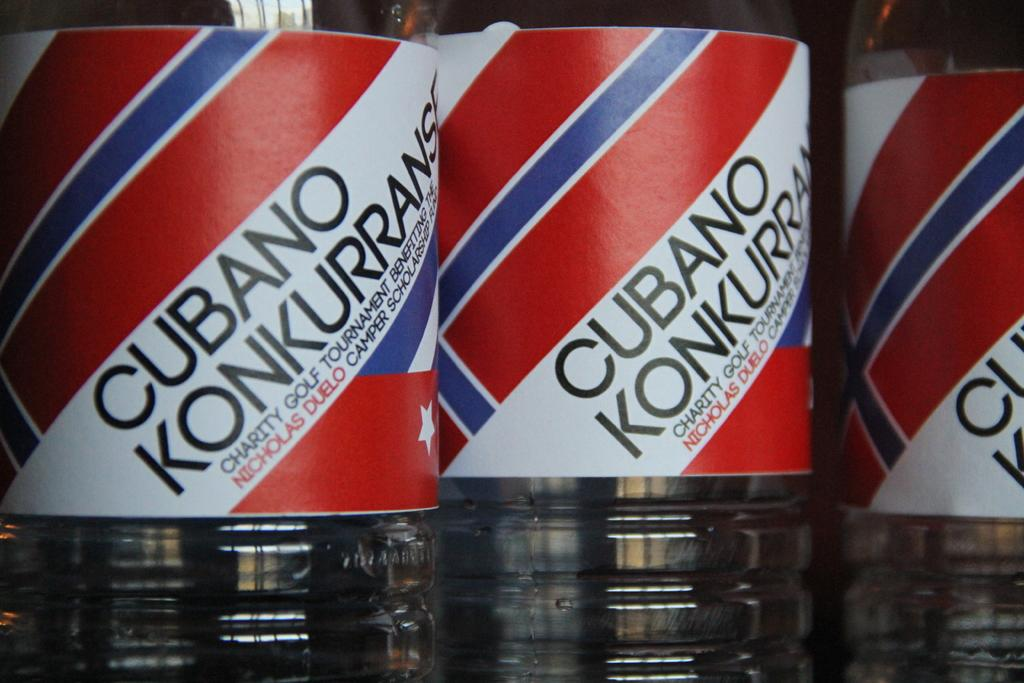<image>
Create a compact narrative representing the image presented. Three bottles have the white, blue and red cubano konkurrans logo on them. 